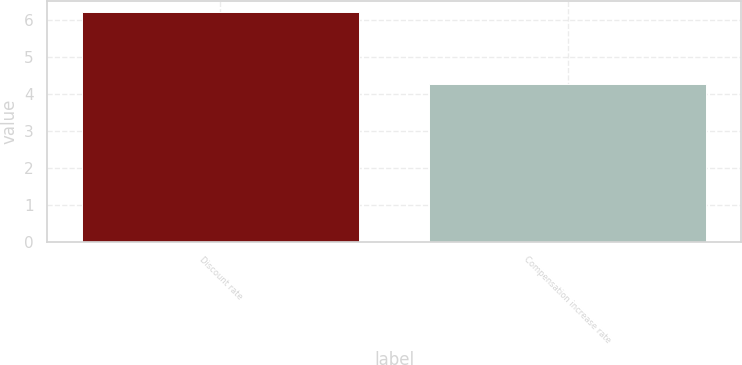<chart> <loc_0><loc_0><loc_500><loc_500><bar_chart><fcel>Discount rate<fcel>Compensation increase rate<nl><fcel>6.2<fcel>4.25<nl></chart> 